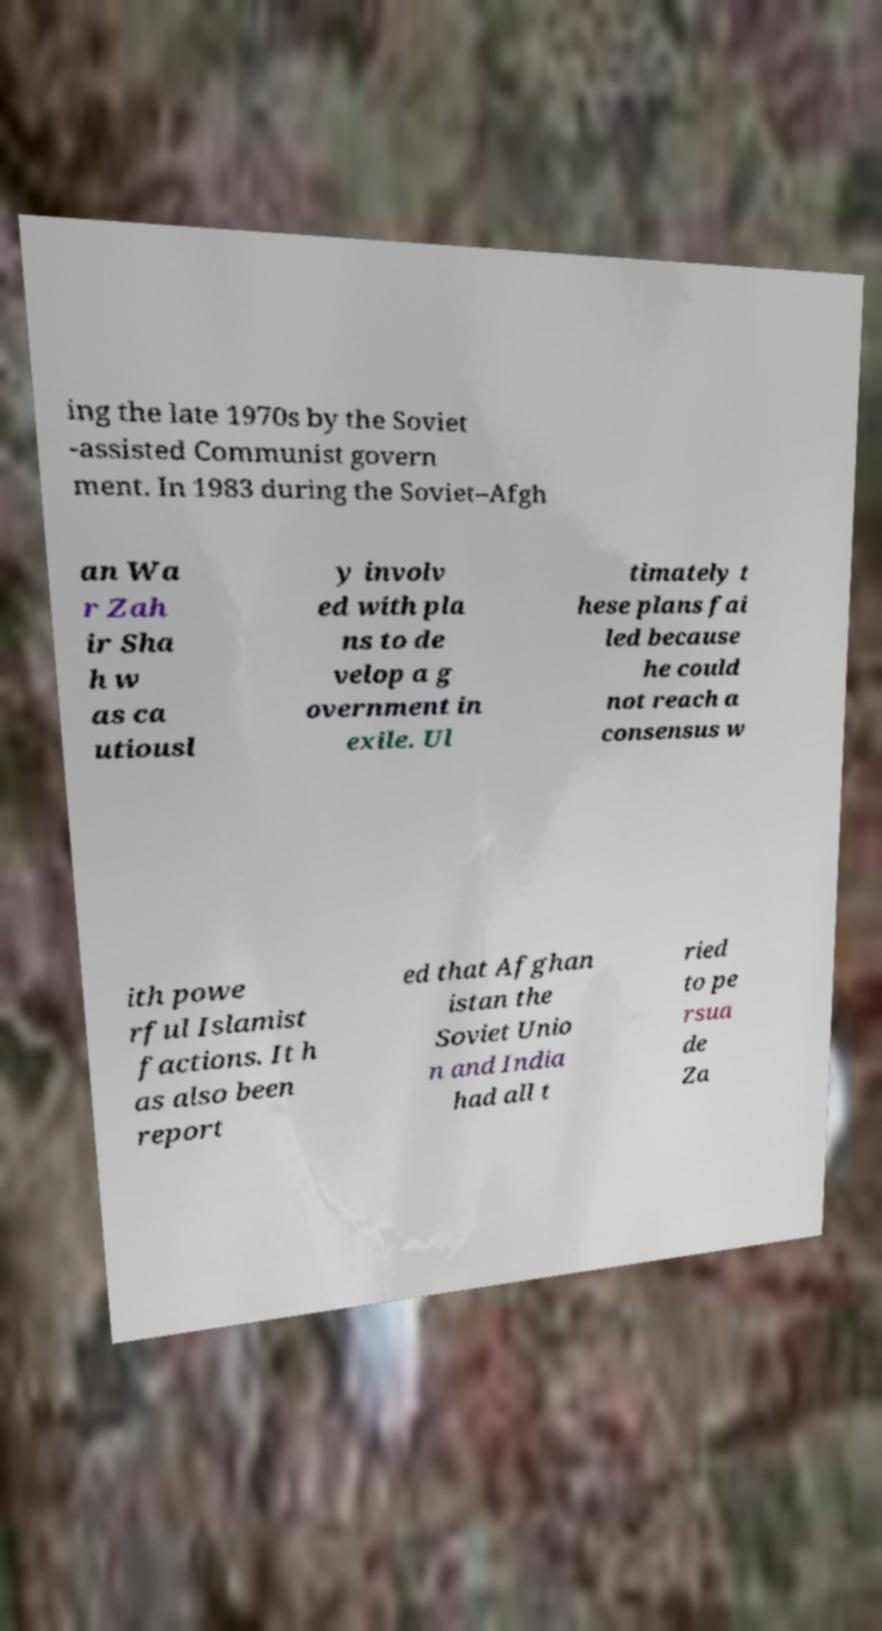What messages or text are displayed in this image? I need them in a readable, typed format. ing the late 1970s by the Soviet -assisted Communist govern ment. In 1983 during the Soviet–Afgh an Wa r Zah ir Sha h w as ca utiousl y involv ed with pla ns to de velop a g overnment in exile. Ul timately t hese plans fai led because he could not reach a consensus w ith powe rful Islamist factions. It h as also been report ed that Afghan istan the Soviet Unio n and India had all t ried to pe rsua de Za 